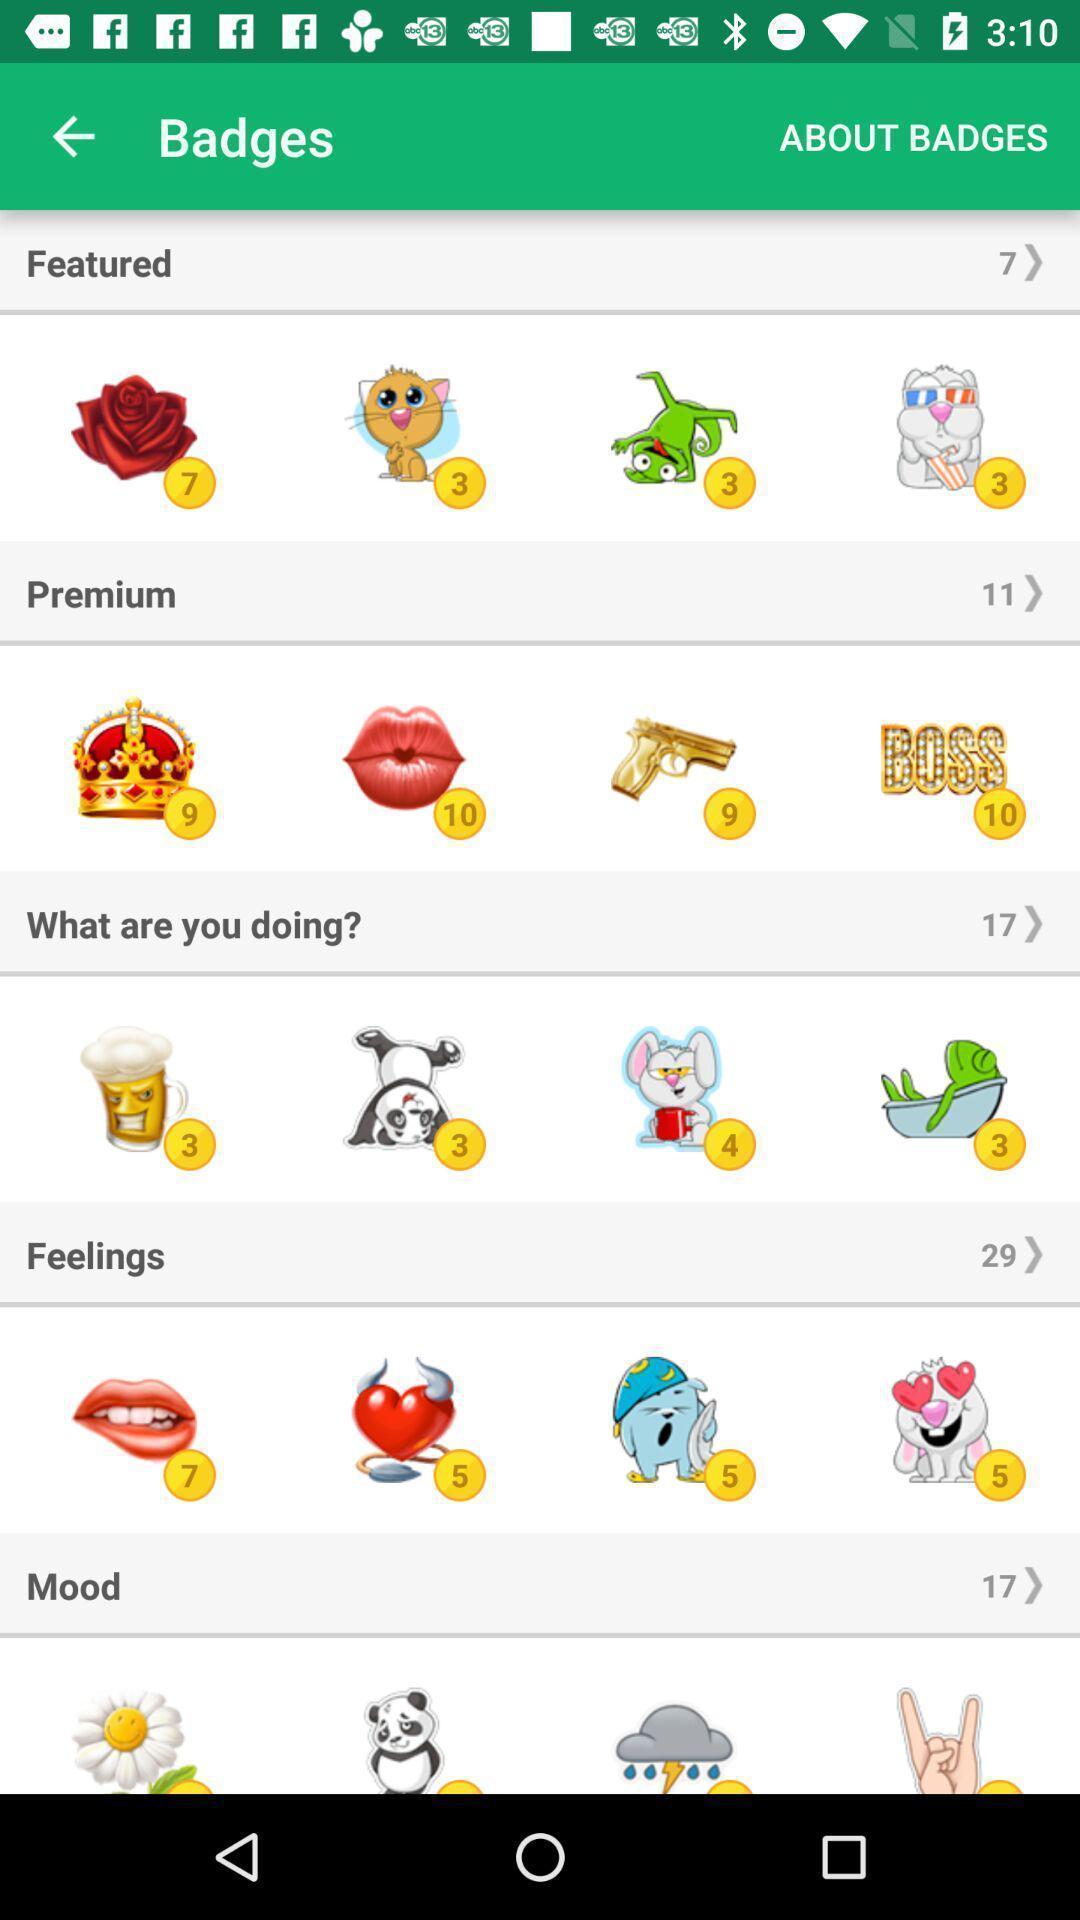Summarize the information in this screenshot. Screen shows about featured badges. 